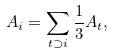<formula> <loc_0><loc_0><loc_500><loc_500>A _ { i } = \sum _ { t \supset i } { \frac { 1 } { 3 } A _ { t } } ,</formula> 